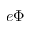<formula> <loc_0><loc_0><loc_500><loc_500>- e \Phi</formula> 